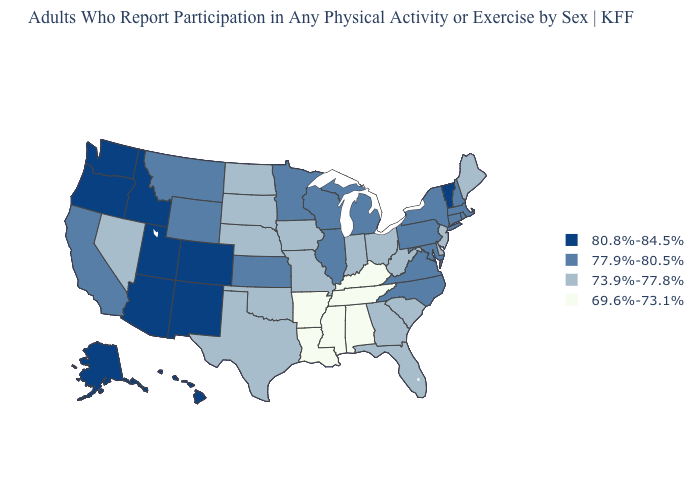What is the lowest value in the USA?
Be succinct. 69.6%-73.1%. What is the value of Delaware?
Answer briefly. 73.9%-77.8%. What is the value of Pennsylvania?
Answer briefly. 77.9%-80.5%. Does New York have the lowest value in the USA?
Give a very brief answer. No. What is the value of West Virginia?
Concise answer only. 73.9%-77.8%. Name the states that have a value in the range 73.9%-77.8%?
Keep it brief. Delaware, Florida, Georgia, Indiana, Iowa, Maine, Missouri, Nebraska, Nevada, New Jersey, North Dakota, Ohio, Oklahoma, South Carolina, South Dakota, Texas, West Virginia. Does Oregon have the highest value in the West?
Write a very short answer. Yes. Does Nevada have the same value as Michigan?
Concise answer only. No. Which states have the lowest value in the USA?
Give a very brief answer. Alabama, Arkansas, Kentucky, Louisiana, Mississippi, Tennessee. What is the value of Montana?
Short answer required. 77.9%-80.5%. Does the map have missing data?
Concise answer only. No. What is the value of Georgia?
Write a very short answer. 73.9%-77.8%. Does the first symbol in the legend represent the smallest category?
Be succinct. No. Does Iowa have a lower value than Virginia?
Give a very brief answer. Yes. What is the value of Utah?
Quick response, please. 80.8%-84.5%. 